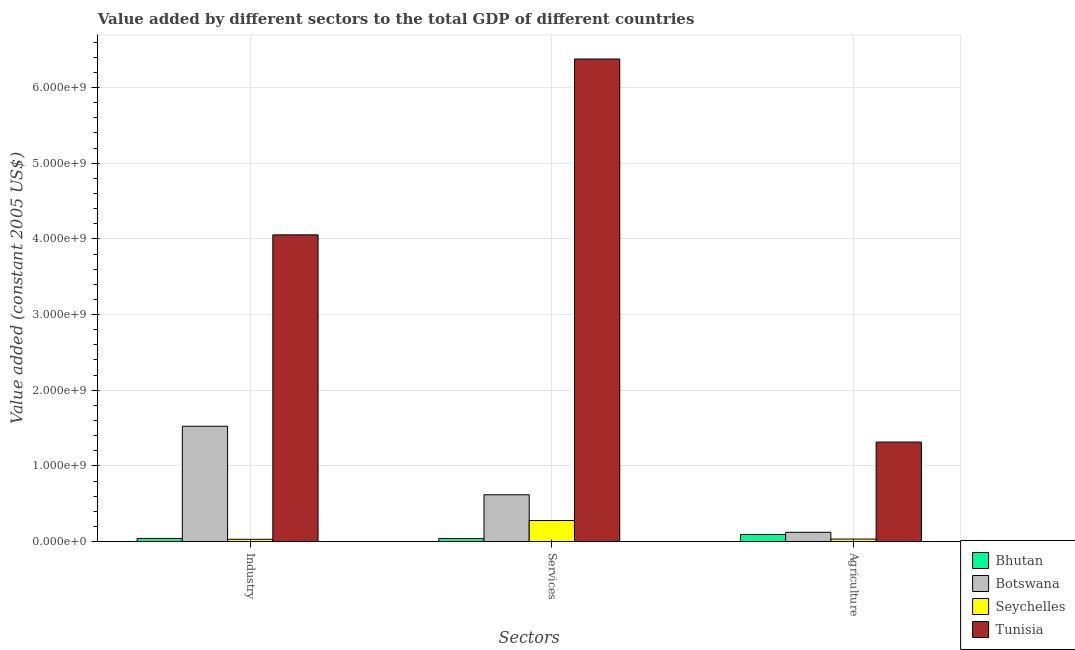How many different coloured bars are there?
Your answer should be very brief. 4. Are the number of bars per tick equal to the number of legend labels?
Make the answer very short. Yes. What is the label of the 2nd group of bars from the left?
Your response must be concise. Services. What is the value added by agricultural sector in Botswana?
Provide a short and direct response. 1.23e+08. Across all countries, what is the maximum value added by services?
Ensure brevity in your answer.  6.38e+09. Across all countries, what is the minimum value added by industrial sector?
Provide a short and direct response. 3.00e+07. In which country was the value added by industrial sector maximum?
Make the answer very short. Tunisia. In which country was the value added by services minimum?
Your answer should be compact. Bhutan. What is the total value added by agricultural sector in the graph?
Provide a short and direct response. 1.56e+09. What is the difference between the value added by agricultural sector in Bhutan and that in Botswana?
Keep it short and to the point. -2.86e+07. What is the difference between the value added by agricultural sector in Bhutan and the value added by industrial sector in Botswana?
Your answer should be very brief. -1.43e+09. What is the average value added by agricultural sector per country?
Your answer should be very brief. 3.91e+08. What is the difference between the value added by industrial sector and value added by services in Botswana?
Provide a short and direct response. 9.06e+08. In how many countries, is the value added by industrial sector greater than 3200000000 US$?
Provide a succinct answer. 1. What is the ratio of the value added by services in Bhutan to that in Botswana?
Provide a short and direct response. 0.06. Is the value added by services in Seychelles less than that in Botswana?
Provide a short and direct response. Yes. What is the difference between the highest and the second highest value added by services?
Your response must be concise. 5.76e+09. What is the difference between the highest and the lowest value added by services?
Ensure brevity in your answer.  6.34e+09. What does the 4th bar from the left in Agriculture represents?
Offer a very short reply. Tunisia. What does the 1st bar from the right in Agriculture represents?
Offer a terse response. Tunisia. How many bars are there?
Give a very brief answer. 12. How many countries are there in the graph?
Provide a short and direct response. 4. Are the values on the major ticks of Y-axis written in scientific E-notation?
Your answer should be very brief. Yes. Does the graph contain grids?
Ensure brevity in your answer.  Yes. How many legend labels are there?
Keep it short and to the point. 4. How are the legend labels stacked?
Offer a terse response. Vertical. What is the title of the graph?
Offer a very short reply. Value added by different sectors to the total GDP of different countries. What is the label or title of the X-axis?
Provide a short and direct response. Sectors. What is the label or title of the Y-axis?
Provide a short and direct response. Value added (constant 2005 US$). What is the Value added (constant 2005 US$) in Bhutan in Industry?
Make the answer very short. 4.15e+07. What is the Value added (constant 2005 US$) in Botswana in Industry?
Keep it short and to the point. 1.52e+09. What is the Value added (constant 2005 US$) of Seychelles in Industry?
Keep it short and to the point. 3.00e+07. What is the Value added (constant 2005 US$) of Tunisia in Industry?
Your answer should be very brief. 4.05e+09. What is the Value added (constant 2005 US$) of Bhutan in Services?
Offer a very short reply. 4.01e+07. What is the Value added (constant 2005 US$) in Botswana in Services?
Provide a succinct answer. 6.18e+08. What is the Value added (constant 2005 US$) of Seychelles in Services?
Make the answer very short. 2.78e+08. What is the Value added (constant 2005 US$) of Tunisia in Services?
Keep it short and to the point. 6.38e+09. What is the Value added (constant 2005 US$) of Bhutan in Agriculture?
Provide a succinct answer. 9.39e+07. What is the Value added (constant 2005 US$) of Botswana in Agriculture?
Ensure brevity in your answer.  1.23e+08. What is the Value added (constant 2005 US$) of Seychelles in Agriculture?
Provide a succinct answer. 3.30e+07. What is the Value added (constant 2005 US$) in Tunisia in Agriculture?
Keep it short and to the point. 1.31e+09. Across all Sectors, what is the maximum Value added (constant 2005 US$) of Bhutan?
Your response must be concise. 9.39e+07. Across all Sectors, what is the maximum Value added (constant 2005 US$) of Botswana?
Keep it short and to the point. 1.52e+09. Across all Sectors, what is the maximum Value added (constant 2005 US$) of Seychelles?
Your answer should be compact. 2.78e+08. Across all Sectors, what is the maximum Value added (constant 2005 US$) of Tunisia?
Ensure brevity in your answer.  6.38e+09. Across all Sectors, what is the minimum Value added (constant 2005 US$) of Bhutan?
Make the answer very short. 4.01e+07. Across all Sectors, what is the minimum Value added (constant 2005 US$) in Botswana?
Your answer should be very brief. 1.23e+08. Across all Sectors, what is the minimum Value added (constant 2005 US$) of Seychelles?
Offer a terse response. 3.00e+07. Across all Sectors, what is the minimum Value added (constant 2005 US$) in Tunisia?
Offer a very short reply. 1.31e+09. What is the total Value added (constant 2005 US$) in Bhutan in the graph?
Your answer should be very brief. 1.75e+08. What is the total Value added (constant 2005 US$) in Botswana in the graph?
Your response must be concise. 2.26e+09. What is the total Value added (constant 2005 US$) in Seychelles in the graph?
Make the answer very short. 3.41e+08. What is the total Value added (constant 2005 US$) in Tunisia in the graph?
Provide a short and direct response. 1.17e+1. What is the difference between the Value added (constant 2005 US$) of Bhutan in Industry and that in Services?
Ensure brevity in your answer.  1.37e+06. What is the difference between the Value added (constant 2005 US$) of Botswana in Industry and that in Services?
Offer a terse response. 9.06e+08. What is the difference between the Value added (constant 2005 US$) in Seychelles in Industry and that in Services?
Provide a succinct answer. -2.48e+08. What is the difference between the Value added (constant 2005 US$) of Tunisia in Industry and that in Services?
Your response must be concise. -2.32e+09. What is the difference between the Value added (constant 2005 US$) of Bhutan in Industry and that in Agriculture?
Provide a succinct answer. -5.25e+07. What is the difference between the Value added (constant 2005 US$) of Botswana in Industry and that in Agriculture?
Your answer should be very brief. 1.40e+09. What is the difference between the Value added (constant 2005 US$) in Seychelles in Industry and that in Agriculture?
Your answer should be compact. -3.06e+06. What is the difference between the Value added (constant 2005 US$) in Tunisia in Industry and that in Agriculture?
Give a very brief answer. 2.74e+09. What is the difference between the Value added (constant 2005 US$) of Bhutan in Services and that in Agriculture?
Provide a short and direct response. -5.39e+07. What is the difference between the Value added (constant 2005 US$) of Botswana in Services and that in Agriculture?
Your answer should be very brief. 4.96e+08. What is the difference between the Value added (constant 2005 US$) in Seychelles in Services and that in Agriculture?
Give a very brief answer. 2.45e+08. What is the difference between the Value added (constant 2005 US$) of Tunisia in Services and that in Agriculture?
Keep it short and to the point. 5.06e+09. What is the difference between the Value added (constant 2005 US$) of Bhutan in Industry and the Value added (constant 2005 US$) of Botswana in Services?
Your response must be concise. -5.77e+08. What is the difference between the Value added (constant 2005 US$) of Bhutan in Industry and the Value added (constant 2005 US$) of Seychelles in Services?
Provide a succinct answer. -2.37e+08. What is the difference between the Value added (constant 2005 US$) in Bhutan in Industry and the Value added (constant 2005 US$) in Tunisia in Services?
Your answer should be very brief. -6.34e+09. What is the difference between the Value added (constant 2005 US$) of Botswana in Industry and the Value added (constant 2005 US$) of Seychelles in Services?
Provide a succinct answer. 1.25e+09. What is the difference between the Value added (constant 2005 US$) in Botswana in Industry and the Value added (constant 2005 US$) in Tunisia in Services?
Provide a succinct answer. -4.85e+09. What is the difference between the Value added (constant 2005 US$) of Seychelles in Industry and the Value added (constant 2005 US$) of Tunisia in Services?
Offer a very short reply. -6.35e+09. What is the difference between the Value added (constant 2005 US$) of Bhutan in Industry and the Value added (constant 2005 US$) of Botswana in Agriculture?
Your response must be concise. -8.11e+07. What is the difference between the Value added (constant 2005 US$) in Bhutan in Industry and the Value added (constant 2005 US$) in Seychelles in Agriculture?
Offer a very short reply. 8.43e+06. What is the difference between the Value added (constant 2005 US$) of Bhutan in Industry and the Value added (constant 2005 US$) of Tunisia in Agriculture?
Your answer should be very brief. -1.27e+09. What is the difference between the Value added (constant 2005 US$) in Botswana in Industry and the Value added (constant 2005 US$) in Seychelles in Agriculture?
Give a very brief answer. 1.49e+09. What is the difference between the Value added (constant 2005 US$) of Botswana in Industry and the Value added (constant 2005 US$) of Tunisia in Agriculture?
Your answer should be very brief. 2.09e+08. What is the difference between the Value added (constant 2005 US$) in Seychelles in Industry and the Value added (constant 2005 US$) in Tunisia in Agriculture?
Offer a very short reply. -1.28e+09. What is the difference between the Value added (constant 2005 US$) of Bhutan in Services and the Value added (constant 2005 US$) of Botswana in Agriculture?
Give a very brief answer. -8.25e+07. What is the difference between the Value added (constant 2005 US$) of Bhutan in Services and the Value added (constant 2005 US$) of Seychelles in Agriculture?
Keep it short and to the point. 7.06e+06. What is the difference between the Value added (constant 2005 US$) in Bhutan in Services and the Value added (constant 2005 US$) in Tunisia in Agriculture?
Offer a very short reply. -1.27e+09. What is the difference between the Value added (constant 2005 US$) in Botswana in Services and the Value added (constant 2005 US$) in Seychelles in Agriculture?
Make the answer very short. 5.85e+08. What is the difference between the Value added (constant 2005 US$) of Botswana in Services and the Value added (constant 2005 US$) of Tunisia in Agriculture?
Provide a short and direct response. -6.97e+08. What is the difference between the Value added (constant 2005 US$) of Seychelles in Services and the Value added (constant 2005 US$) of Tunisia in Agriculture?
Make the answer very short. -1.04e+09. What is the average Value added (constant 2005 US$) of Bhutan per Sectors?
Your answer should be very brief. 5.85e+07. What is the average Value added (constant 2005 US$) of Botswana per Sectors?
Provide a short and direct response. 7.55e+08. What is the average Value added (constant 2005 US$) of Seychelles per Sectors?
Offer a very short reply. 1.14e+08. What is the average Value added (constant 2005 US$) of Tunisia per Sectors?
Ensure brevity in your answer.  3.91e+09. What is the difference between the Value added (constant 2005 US$) of Bhutan and Value added (constant 2005 US$) of Botswana in Industry?
Ensure brevity in your answer.  -1.48e+09. What is the difference between the Value added (constant 2005 US$) of Bhutan and Value added (constant 2005 US$) of Seychelles in Industry?
Offer a very short reply. 1.15e+07. What is the difference between the Value added (constant 2005 US$) of Bhutan and Value added (constant 2005 US$) of Tunisia in Industry?
Make the answer very short. -4.01e+09. What is the difference between the Value added (constant 2005 US$) in Botswana and Value added (constant 2005 US$) in Seychelles in Industry?
Provide a succinct answer. 1.49e+09. What is the difference between the Value added (constant 2005 US$) in Botswana and Value added (constant 2005 US$) in Tunisia in Industry?
Your response must be concise. -2.53e+09. What is the difference between the Value added (constant 2005 US$) of Seychelles and Value added (constant 2005 US$) of Tunisia in Industry?
Give a very brief answer. -4.02e+09. What is the difference between the Value added (constant 2005 US$) in Bhutan and Value added (constant 2005 US$) in Botswana in Services?
Your response must be concise. -5.78e+08. What is the difference between the Value added (constant 2005 US$) in Bhutan and Value added (constant 2005 US$) in Seychelles in Services?
Keep it short and to the point. -2.38e+08. What is the difference between the Value added (constant 2005 US$) in Bhutan and Value added (constant 2005 US$) in Tunisia in Services?
Your answer should be very brief. -6.34e+09. What is the difference between the Value added (constant 2005 US$) of Botswana and Value added (constant 2005 US$) of Seychelles in Services?
Your answer should be compact. 3.40e+08. What is the difference between the Value added (constant 2005 US$) in Botswana and Value added (constant 2005 US$) in Tunisia in Services?
Your answer should be very brief. -5.76e+09. What is the difference between the Value added (constant 2005 US$) in Seychelles and Value added (constant 2005 US$) in Tunisia in Services?
Your answer should be compact. -6.10e+09. What is the difference between the Value added (constant 2005 US$) in Bhutan and Value added (constant 2005 US$) in Botswana in Agriculture?
Make the answer very short. -2.86e+07. What is the difference between the Value added (constant 2005 US$) in Bhutan and Value added (constant 2005 US$) in Seychelles in Agriculture?
Provide a succinct answer. 6.09e+07. What is the difference between the Value added (constant 2005 US$) of Bhutan and Value added (constant 2005 US$) of Tunisia in Agriculture?
Give a very brief answer. -1.22e+09. What is the difference between the Value added (constant 2005 US$) of Botswana and Value added (constant 2005 US$) of Seychelles in Agriculture?
Keep it short and to the point. 8.96e+07. What is the difference between the Value added (constant 2005 US$) in Botswana and Value added (constant 2005 US$) in Tunisia in Agriculture?
Offer a very short reply. -1.19e+09. What is the difference between the Value added (constant 2005 US$) of Seychelles and Value added (constant 2005 US$) of Tunisia in Agriculture?
Provide a short and direct response. -1.28e+09. What is the ratio of the Value added (constant 2005 US$) in Bhutan in Industry to that in Services?
Your answer should be compact. 1.03. What is the ratio of the Value added (constant 2005 US$) of Botswana in Industry to that in Services?
Provide a succinct answer. 2.46. What is the ratio of the Value added (constant 2005 US$) of Seychelles in Industry to that in Services?
Ensure brevity in your answer.  0.11. What is the ratio of the Value added (constant 2005 US$) of Tunisia in Industry to that in Services?
Provide a succinct answer. 0.64. What is the ratio of the Value added (constant 2005 US$) in Bhutan in Industry to that in Agriculture?
Provide a short and direct response. 0.44. What is the ratio of the Value added (constant 2005 US$) of Botswana in Industry to that in Agriculture?
Make the answer very short. 12.43. What is the ratio of the Value added (constant 2005 US$) in Seychelles in Industry to that in Agriculture?
Offer a very short reply. 0.91. What is the ratio of the Value added (constant 2005 US$) of Tunisia in Industry to that in Agriculture?
Ensure brevity in your answer.  3.08. What is the ratio of the Value added (constant 2005 US$) in Bhutan in Services to that in Agriculture?
Provide a succinct answer. 0.43. What is the ratio of the Value added (constant 2005 US$) of Botswana in Services to that in Agriculture?
Keep it short and to the point. 5.04. What is the ratio of the Value added (constant 2005 US$) of Seychelles in Services to that in Agriculture?
Offer a very short reply. 8.42. What is the ratio of the Value added (constant 2005 US$) in Tunisia in Services to that in Agriculture?
Your answer should be compact. 4.85. What is the difference between the highest and the second highest Value added (constant 2005 US$) in Bhutan?
Keep it short and to the point. 5.25e+07. What is the difference between the highest and the second highest Value added (constant 2005 US$) in Botswana?
Keep it short and to the point. 9.06e+08. What is the difference between the highest and the second highest Value added (constant 2005 US$) of Seychelles?
Provide a succinct answer. 2.45e+08. What is the difference between the highest and the second highest Value added (constant 2005 US$) in Tunisia?
Provide a succinct answer. 2.32e+09. What is the difference between the highest and the lowest Value added (constant 2005 US$) of Bhutan?
Keep it short and to the point. 5.39e+07. What is the difference between the highest and the lowest Value added (constant 2005 US$) in Botswana?
Provide a succinct answer. 1.40e+09. What is the difference between the highest and the lowest Value added (constant 2005 US$) of Seychelles?
Ensure brevity in your answer.  2.48e+08. What is the difference between the highest and the lowest Value added (constant 2005 US$) of Tunisia?
Keep it short and to the point. 5.06e+09. 